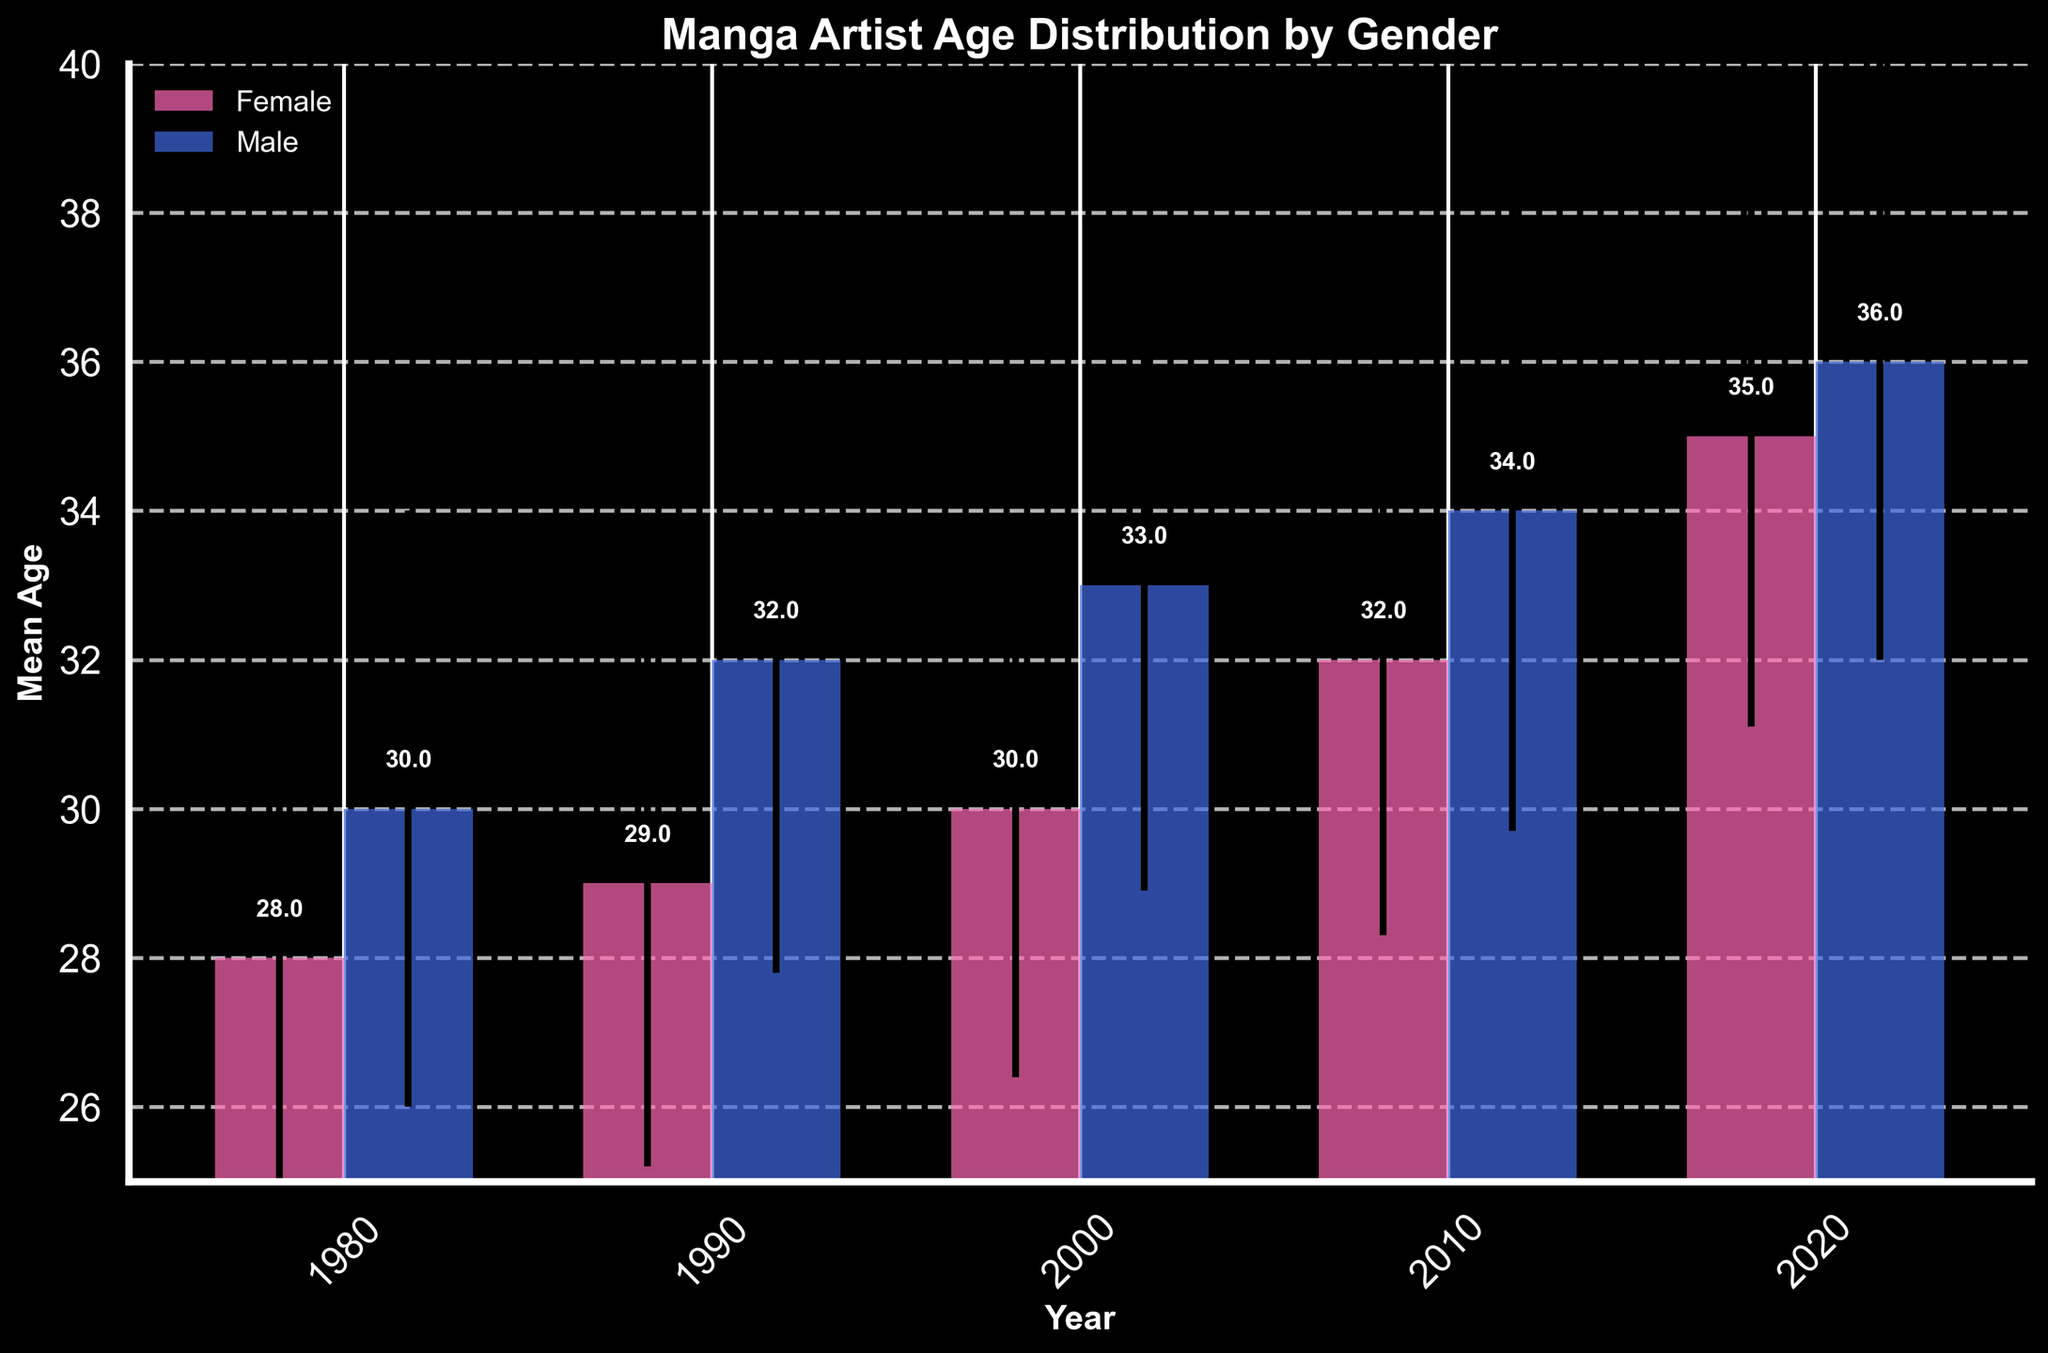What is the title of the figure? The title of the figure is prominently displayed at the top, which is "Manga Artist Age Distribution by Gender".
Answer: Manga Artist Age Distribution by Gender How many different years are displayed in the figure? The x-axis shows the different years displayed in the figure, and by counting the labels, we can see there are five different years: 1980, 1990, 2000, 2010, and 2020.
Answer: 5 Which gender had a higher mean age in 2020? By comparing the heights of the bars for 2020, the bar for male artists is higher than the bar for female artists, indicating that male artists had a higher mean age.
Answer: Male What is the mean age of female manga artists in 2010? Referring to the height of the bar for female artists in 2010, the mean age is clearly marked as 32.
Answer: 32 Between 1980 and 2020, how did the mean ages of male and female manga artists change? To answer this, we look at the heights of the bars for 1980 and 2020. For female artists, the mean age increased from 28 to 35. For male artists, it increased from 30 to 36. The change can be calculated as 35 - 28 = 7 for females and 36 - 30 = 6 for males.
Answer: Female: +7, Male: +6 Which year shows the smallest difference between the mean ages of male and female manga artists? By examining the bars for each year and evaluating the differences: 
1980: 30 - 28 = 2
1990: 32 - 29 = 3
2000: 33 - 30 = 3
2010: 34 - 32 = 2
2020: 36 - 35 = 1
The smallest difference is in the year 2020.
Answer: 2020 What was the standard deviation for male manga artists in 1990? Referring to the error bars for male artists in 1990, the standard deviation is noted. The error bar is positioned at 32 ± 4.2.
Answer: 4.2 Compare the mean age of female manga artists in 1990 and 2000. By inspecting the bar heights for female artists in 1990 and 2000:
1990: 29
2000: 30
The mean age increased by 30 - 29 = 1 year from 1990 to 2000.
Answer: Increased by 1 year In which year did male manga artists have the highest mean age? Observing the highest point reached by the male artist bars, the highest mean age is 36, which occurs in the year 2020.
Answer: 2020 What is the trend observed in the mean age of female manga artists from 1980 to 2020? By examining the female artist bars across the years, we observe a consistent increase in mean age from 28 (1980) to 35 (2020). This shows an upward trend.
Answer: Upward trend 